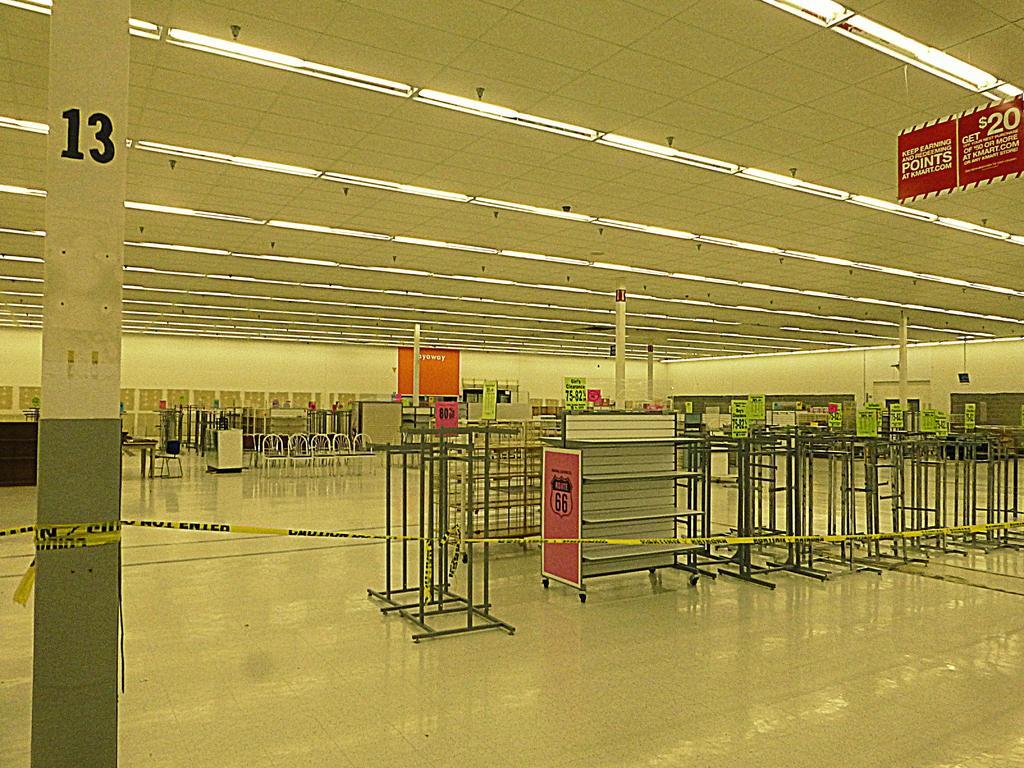Could you give a brief overview of what you see in this image? In a hall there are poles and other objects. 